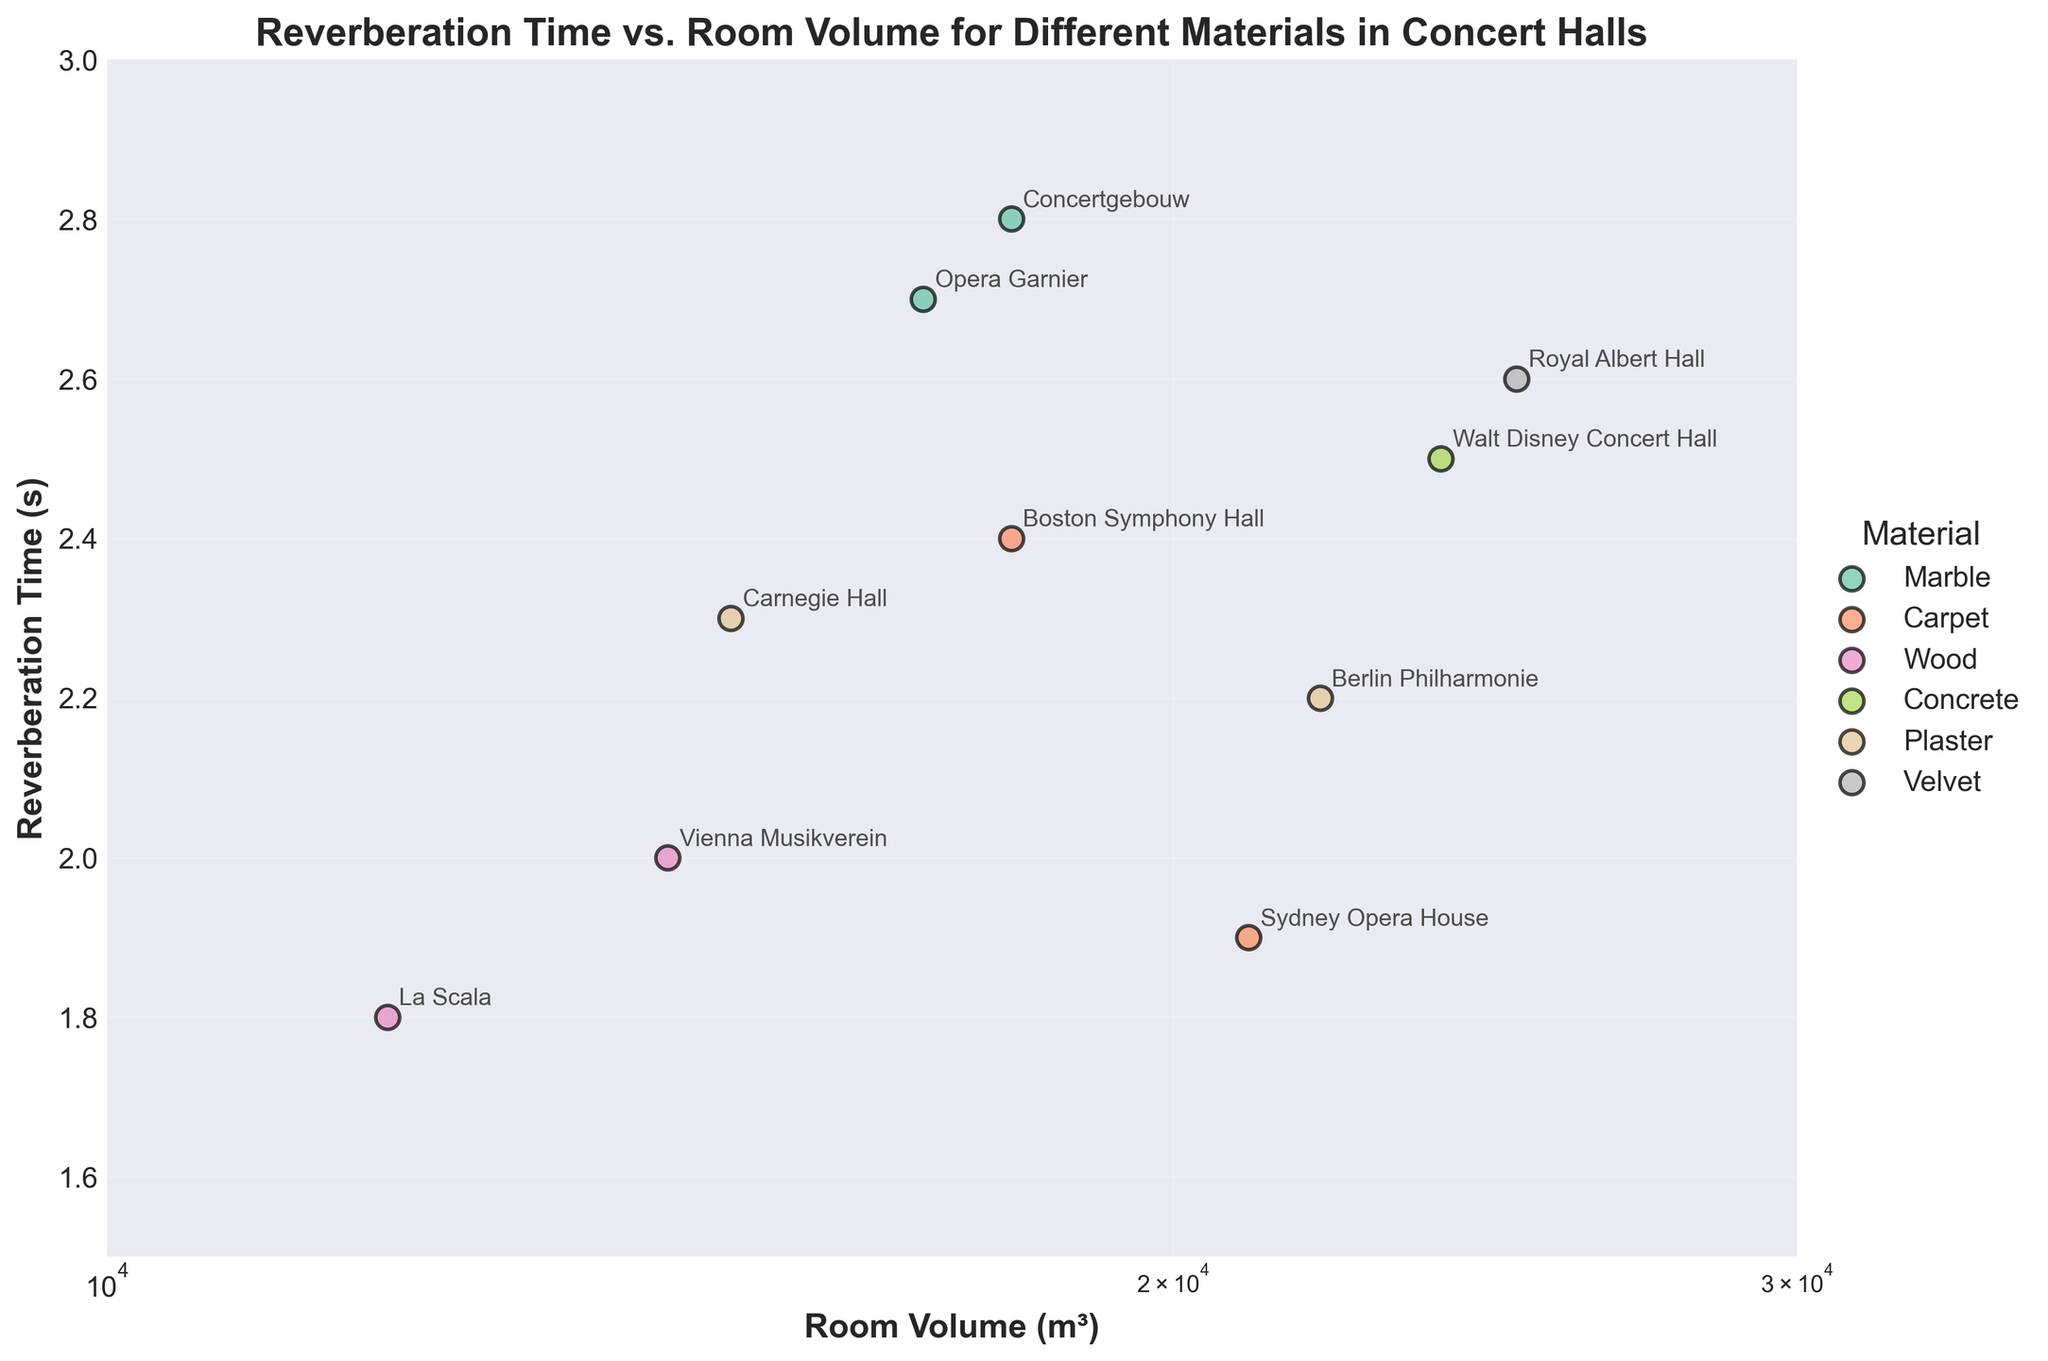What is the general trend between room volume and reverberation time shown in the scatter plot? Generally, as the room volume increases, the reverberation time also increases, although there are some variations depending on the material.
Answer: As room volume increases, reverberation time generally increases How many materials are compared in the scatter plot? There are seven distinct colors (one for each material) indicated in the legend, suggesting seven different materials.
Answer: Seven materials Which room has the longest reverberation time among those with marble material? The rooms with marble material are Concertgebouw and Opera Garnier, with Opera Garnier having a reverberation time of 2.7 seconds, which is longer.
Answer: Opera Garnier How does the reverberation time of the Sydney Opera House compare to that of the Berlin Philharmonie? The Sydney Opera House reverberation time is 1.9 seconds, and that of the Berlin Philharmonie is 2.2 seconds. Sydney Opera House has a shorter reverberation time.
Answer: Sydney Opera House has a shorter reverberation time Which room has the smallest volume, and what material is used in it? The smallest room volume is 12000 m³, which belongs to La Scala and uses wood material.
Answer: La Scala, wood What is the range of room volumes shown in the plot? The smallest volume is 12000 m³, and the largest volume is 25000 m³. The range is 25000 - 12000 = 13000 m³.
Answer: 13000 m³ Which rooms have the same room volume but different reverberation times? Concertgebouw and Boston Symphony Hall both have a room volume of 18000 m³. Their reverberation times are 2.8 and 2.4 seconds, respectively.
Answer: Concertgebouw and Boston Symphony Hall What material is associated with the room that has the longest reverberation time? The longest reverberation time is 2.8 seconds, belonging to Concertgebouw, which uses marble.
Answer: Marble What is the average reverberation time for rooms with wood material? The rooms with wood material are Vienna Musikverein and La Scala, with reverberation times of 2.0 and 1.8 seconds. The average is (2.0 + 1.8) / 2 = 1.9 seconds.
Answer: 1.9 seconds Which room has the highest reverberation time relative to its volume size? To find this, divide reverberation time by room volume for each room. The calculation shows that Concertgebouw has the highest ratio, having the highest reverberation time of 2.8 seconds for 18000 m³.
Answer: Concertgebouw 